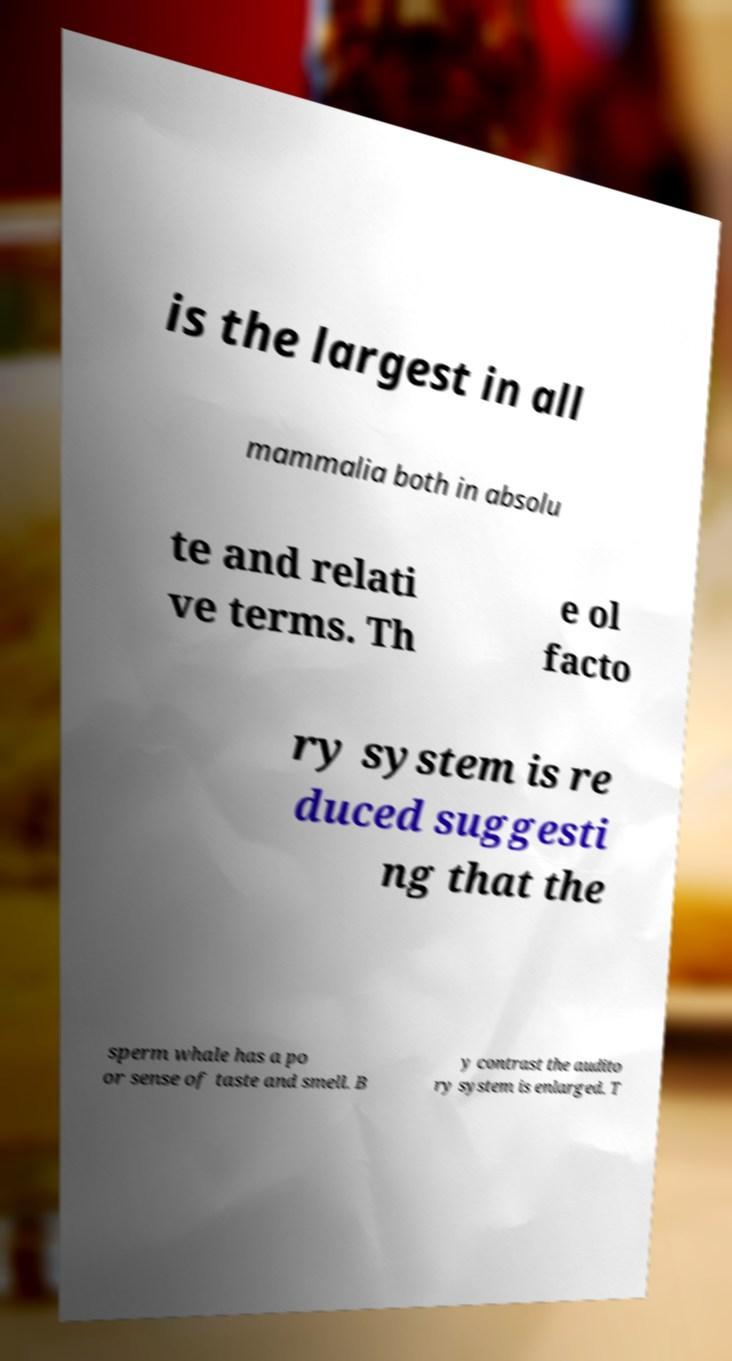Could you extract and type out the text from this image? is the largest in all mammalia both in absolu te and relati ve terms. Th e ol facto ry system is re duced suggesti ng that the sperm whale has a po or sense of taste and smell. B y contrast the audito ry system is enlarged. T 